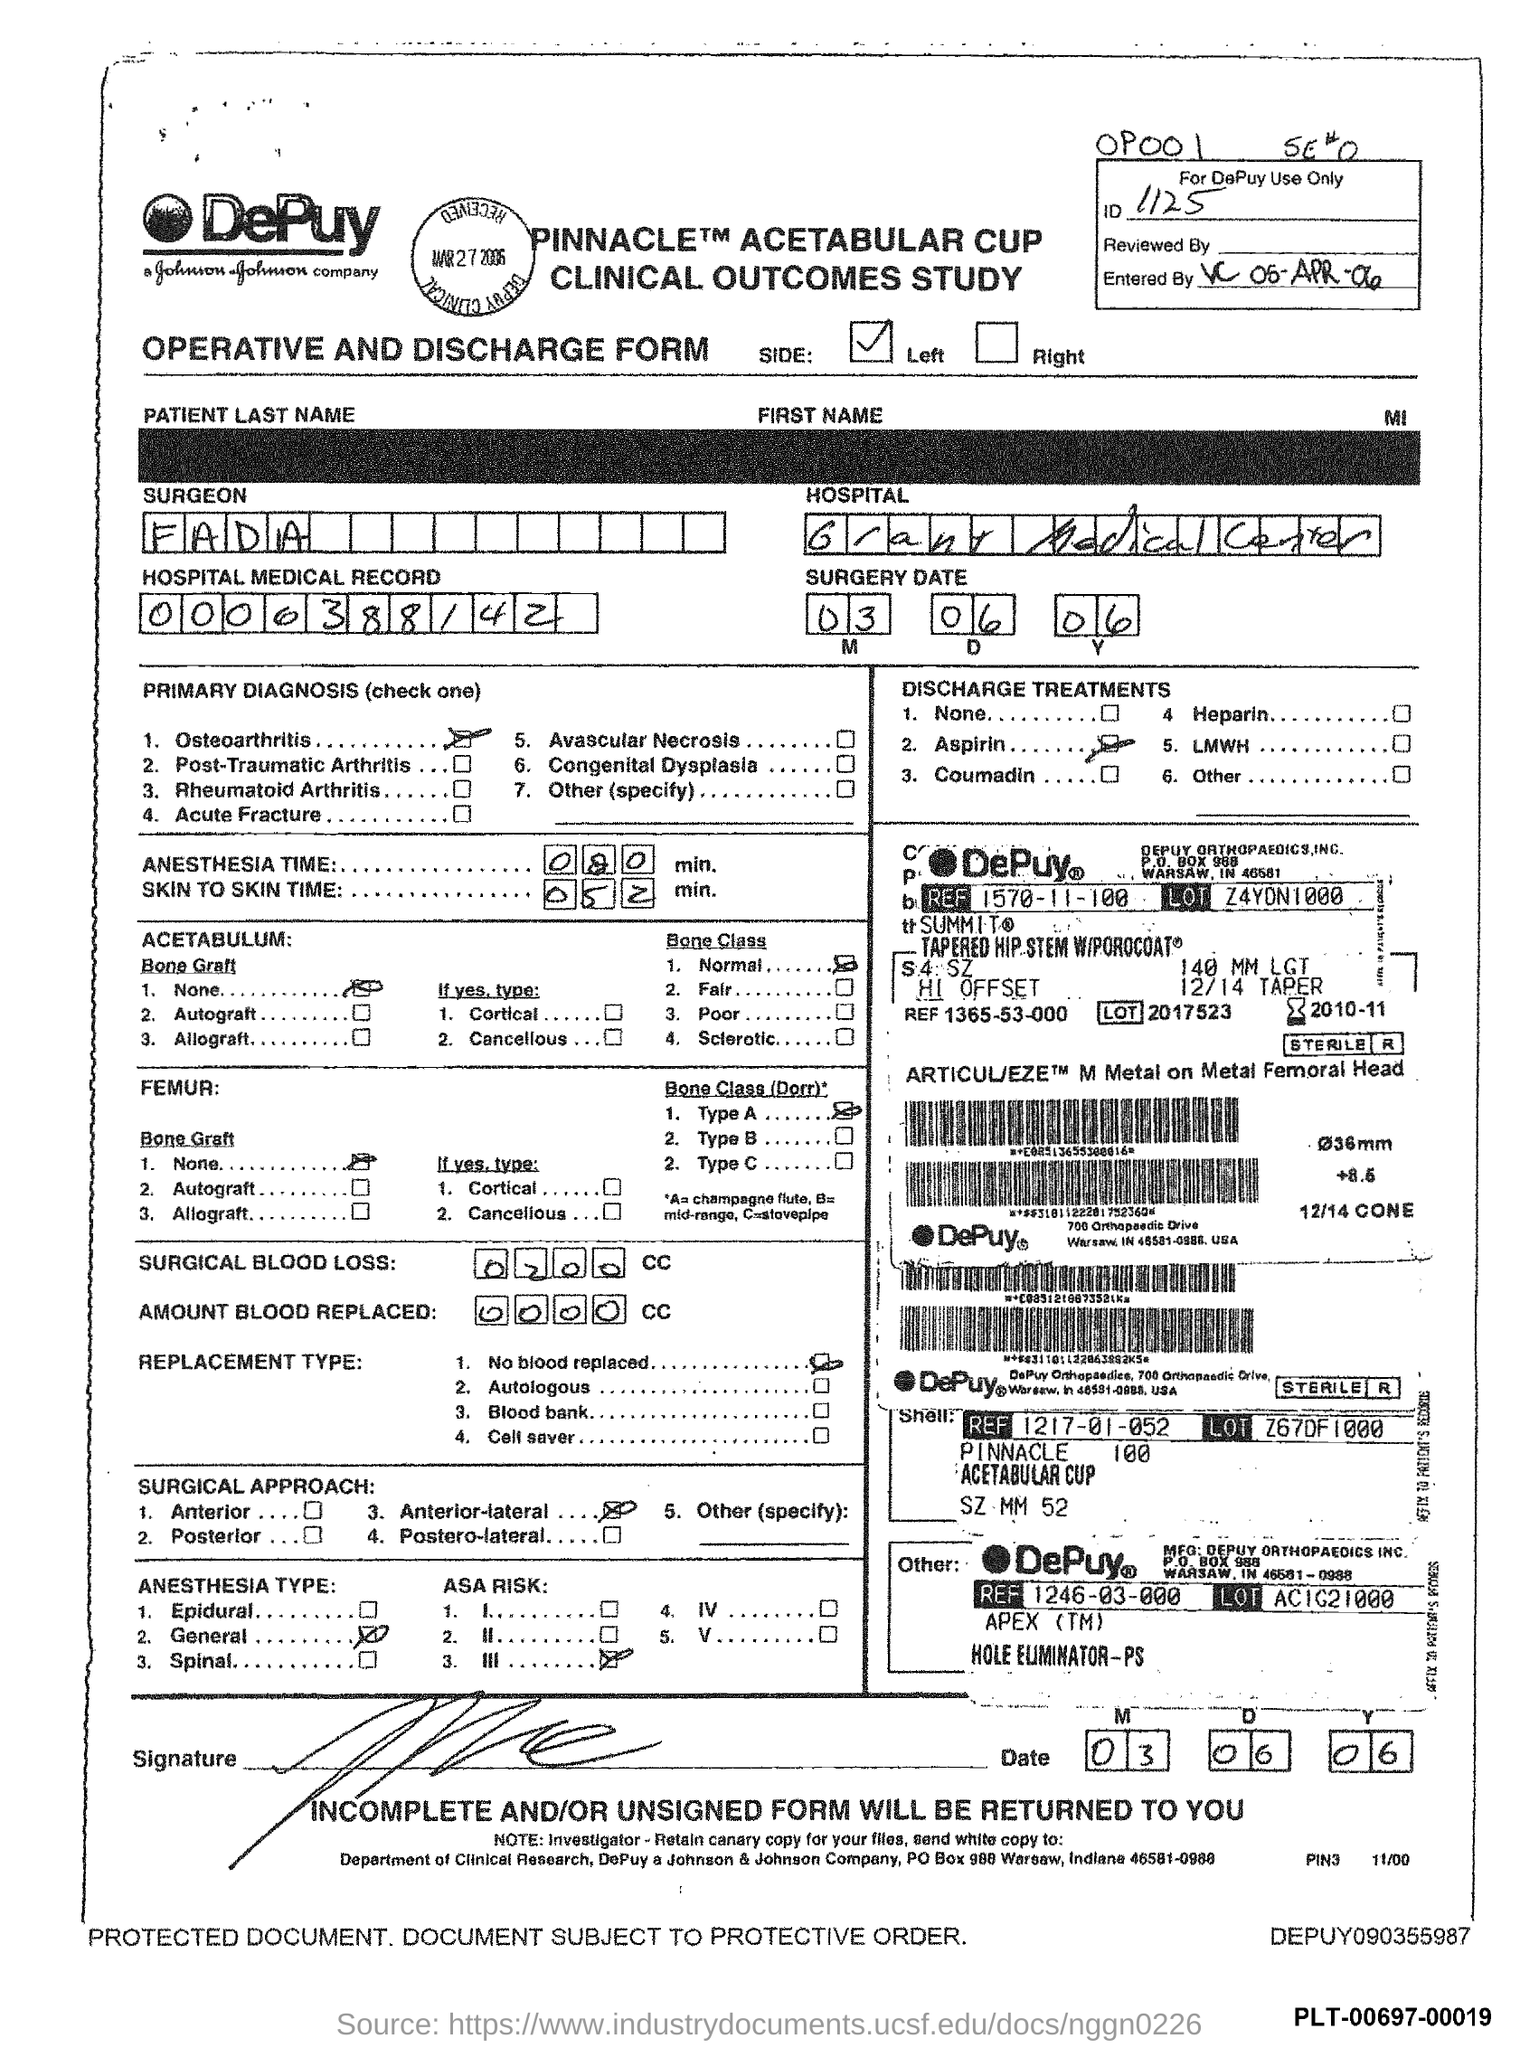List a handful of essential elements in this visual. The ID number is 1125. The surgeon's name is Fada. 